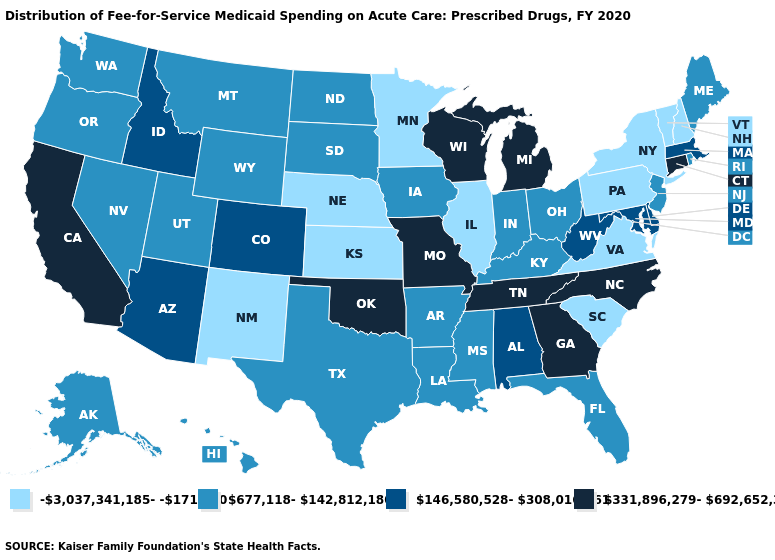What is the value of Delaware?
Write a very short answer. 146,580,528-308,016,261. What is the value of Georgia?
Be succinct. 331,896,279-692,652,315. How many symbols are there in the legend?
Keep it brief. 4. Among the states that border North Carolina , does Georgia have the highest value?
Keep it brief. Yes. Which states have the lowest value in the USA?
Write a very short answer. Illinois, Kansas, Minnesota, Nebraska, New Hampshire, New Mexico, New York, Pennsylvania, South Carolina, Vermont, Virginia. Name the states that have a value in the range 331,896,279-692,652,315?
Short answer required. California, Connecticut, Georgia, Michigan, Missouri, North Carolina, Oklahoma, Tennessee, Wisconsin. Does the map have missing data?
Write a very short answer. No. Name the states that have a value in the range 146,580,528-308,016,261?
Concise answer only. Alabama, Arizona, Colorado, Delaware, Idaho, Maryland, Massachusetts, West Virginia. Does North Carolina have the same value as Montana?
Quick response, please. No. What is the highest value in states that border Minnesota?
Write a very short answer. 331,896,279-692,652,315. What is the value of Nevada?
Short answer required. 677,118-142,812,180. Name the states that have a value in the range 331,896,279-692,652,315?
Keep it brief. California, Connecticut, Georgia, Michigan, Missouri, North Carolina, Oklahoma, Tennessee, Wisconsin. What is the value of Kansas?
Be succinct. -3,037,341,185--171,620. What is the highest value in the South ?
Write a very short answer. 331,896,279-692,652,315. Name the states that have a value in the range 146,580,528-308,016,261?
Keep it brief. Alabama, Arizona, Colorado, Delaware, Idaho, Maryland, Massachusetts, West Virginia. 